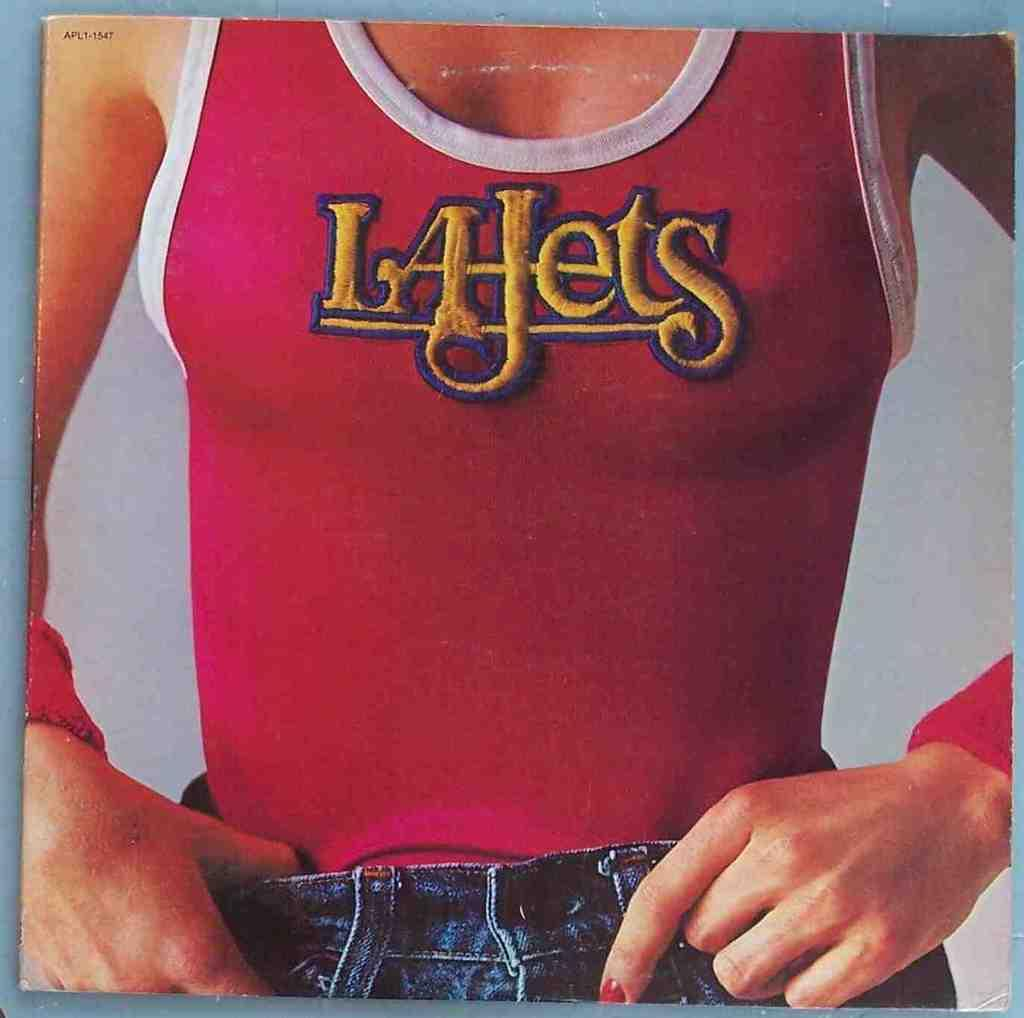<image>
Offer a succinct explanation of the picture presented. A woman's torso is displayed wearing an LA Jets tanktop. 